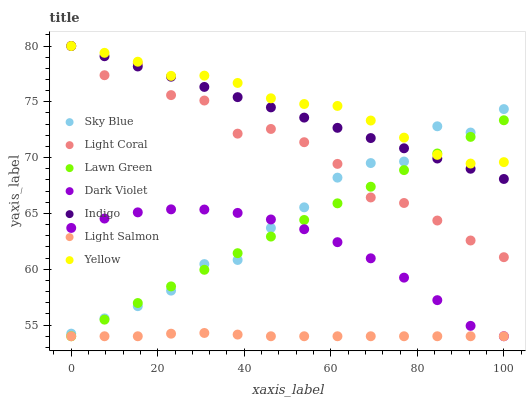Does Light Salmon have the minimum area under the curve?
Answer yes or no. Yes. Does Yellow have the maximum area under the curve?
Answer yes or no. Yes. Does Indigo have the minimum area under the curve?
Answer yes or no. No. Does Indigo have the maximum area under the curve?
Answer yes or no. No. Is Lawn Green the smoothest?
Answer yes or no. Yes. Is Light Coral the roughest?
Answer yes or no. Yes. Is Light Salmon the smoothest?
Answer yes or no. No. Is Light Salmon the roughest?
Answer yes or no. No. Does Lawn Green have the lowest value?
Answer yes or no. Yes. Does Indigo have the lowest value?
Answer yes or no. No. Does Yellow have the highest value?
Answer yes or no. Yes. Does Light Salmon have the highest value?
Answer yes or no. No. Is Light Salmon less than Sky Blue?
Answer yes or no. Yes. Is Yellow greater than Light Salmon?
Answer yes or no. Yes. Does Lawn Green intersect Indigo?
Answer yes or no. Yes. Is Lawn Green less than Indigo?
Answer yes or no. No. Is Lawn Green greater than Indigo?
Answer yes or no. No. Does Light Salmon intersect Sky Blue?
Answer yes or no. No. 